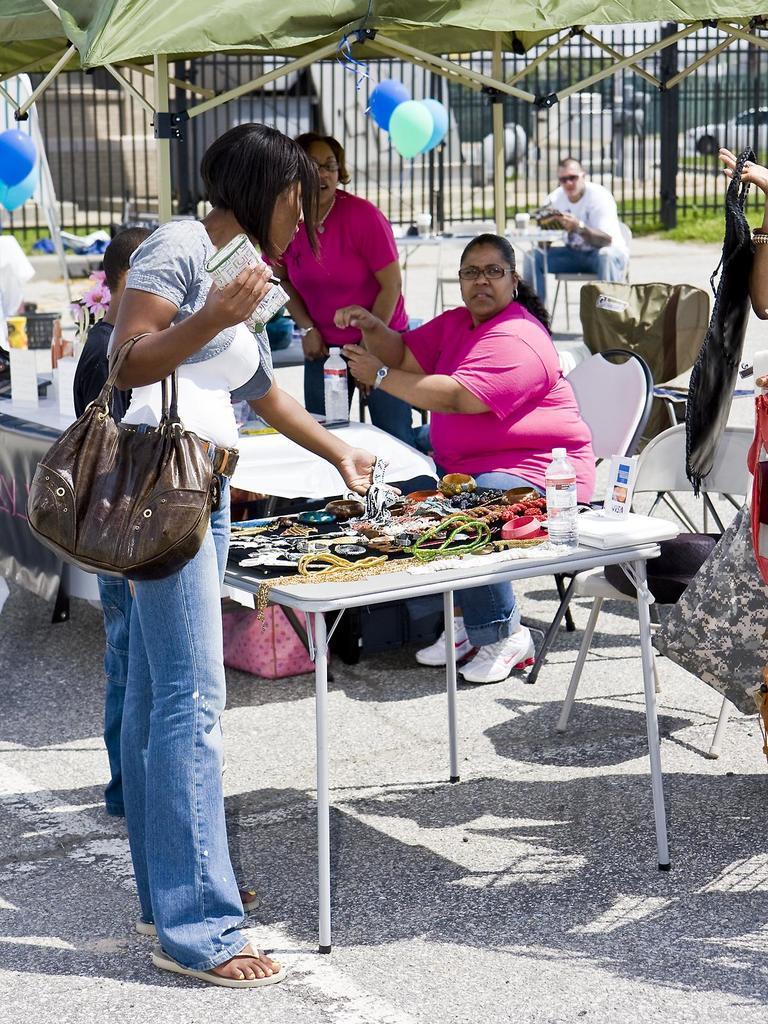How would you summarize this image in a sentence or two? In this image I can see number of people were few of them are sitting and few are standing. I can also see balloons and a tent. 